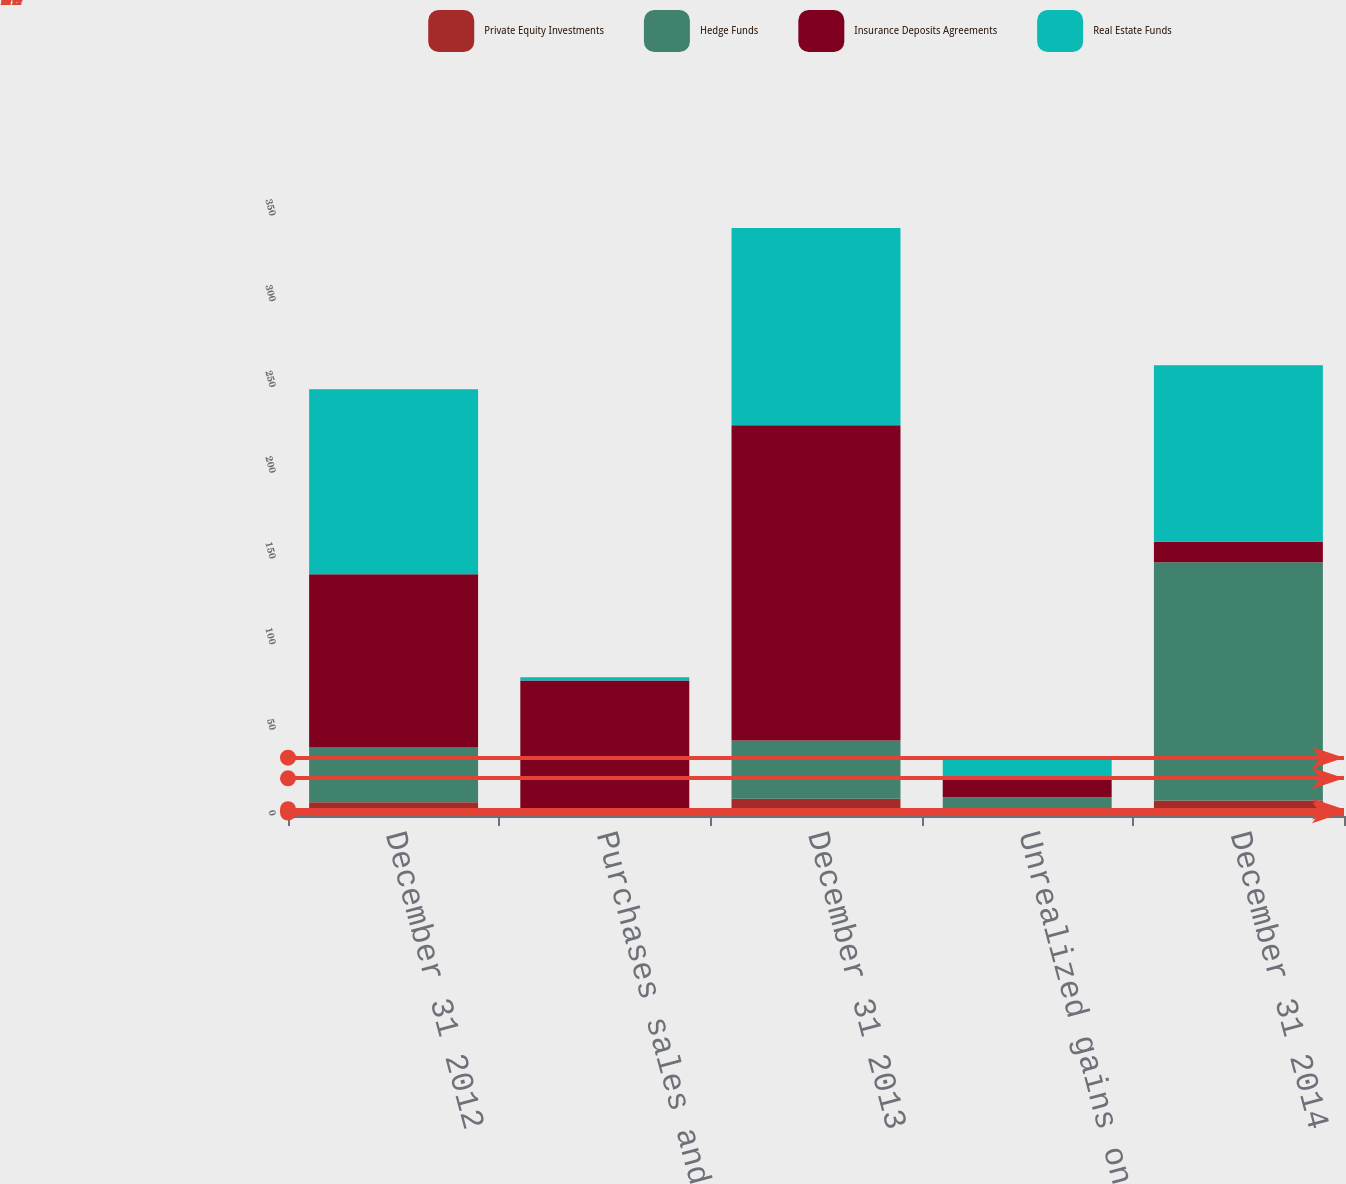Convert chart. <chart><loc_0><loc_0><loc_500><loc_500><stacked_bar_chart><ecel><fcel>December 31 2012<fcel>Purchases sales and<fcel>December 31 2013<fcel>Unrealized gains on plan<fcel>December 31 2014<nl><fcel>Private Equity Investments<fcel>8<fcel>2<fcel>10<fcel>2<fcel>9<nl><fcel>Hedge Funds<fcel>32<fcel>2<fcel>34<fcel>9<fcel>139<nl><fcel>Insurance Deposits Agreements<fcel>101<fcel>75<fcel>184<fcel>11<fcel>12<nl><fcel>Real Estate Funds<fcel>108<fcel>2<fcel>115<fcel>12<fcel>103<nl></chart> 